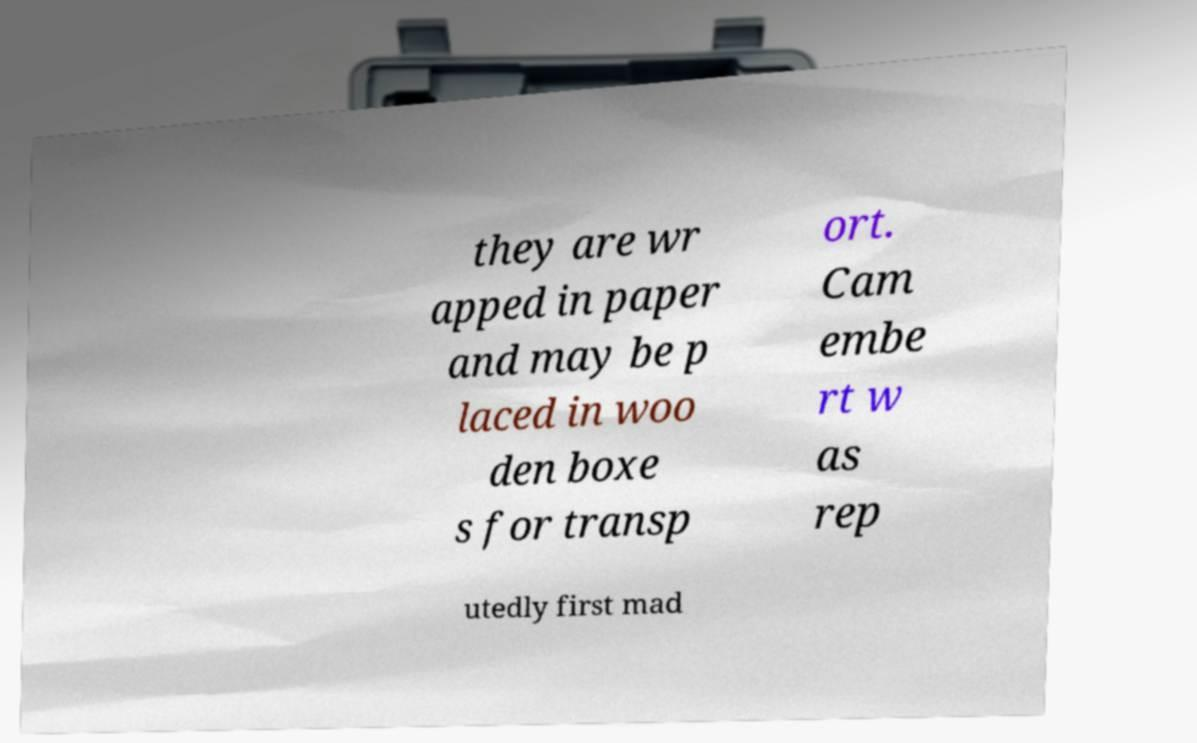Can you accurately transcribe the text from the provided image for me? they are wr apped in paper and may be p laced in woo den boxe s for transp ort. Cam embe rt w as rep utedly first mad 